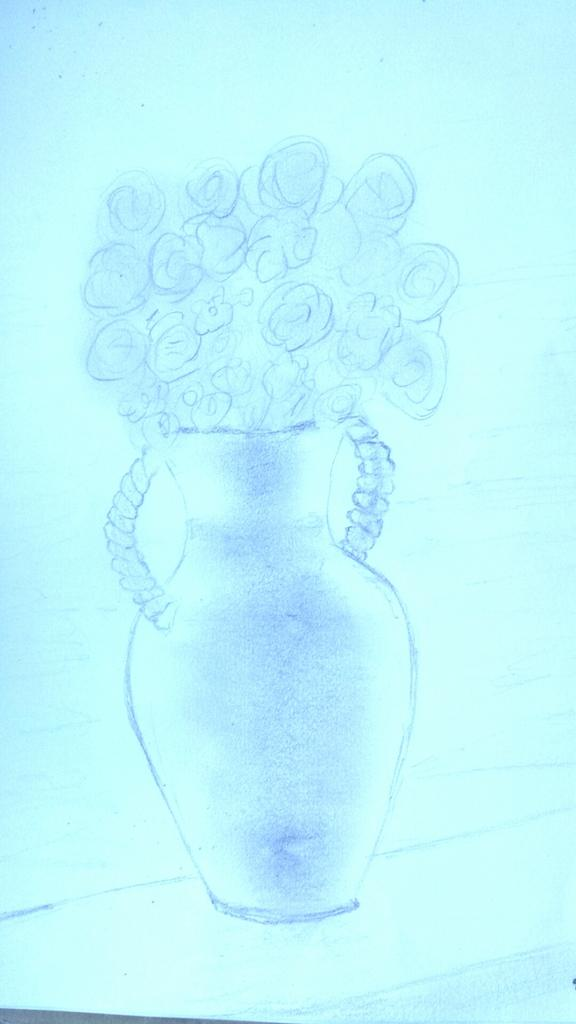What is depicted in the drawing in the image? There is a drawing of a flower vase in the image. What is the color of the paper on which the drawing is made? The drawing is on blue color paper. What is inside the flower vase in the drawing? The flower vase contains flowers. How many children are playing with cars near the flower vase in the image? There are no children or cars present in the image; it only features a drawing of a flower vase on blue color paper. 